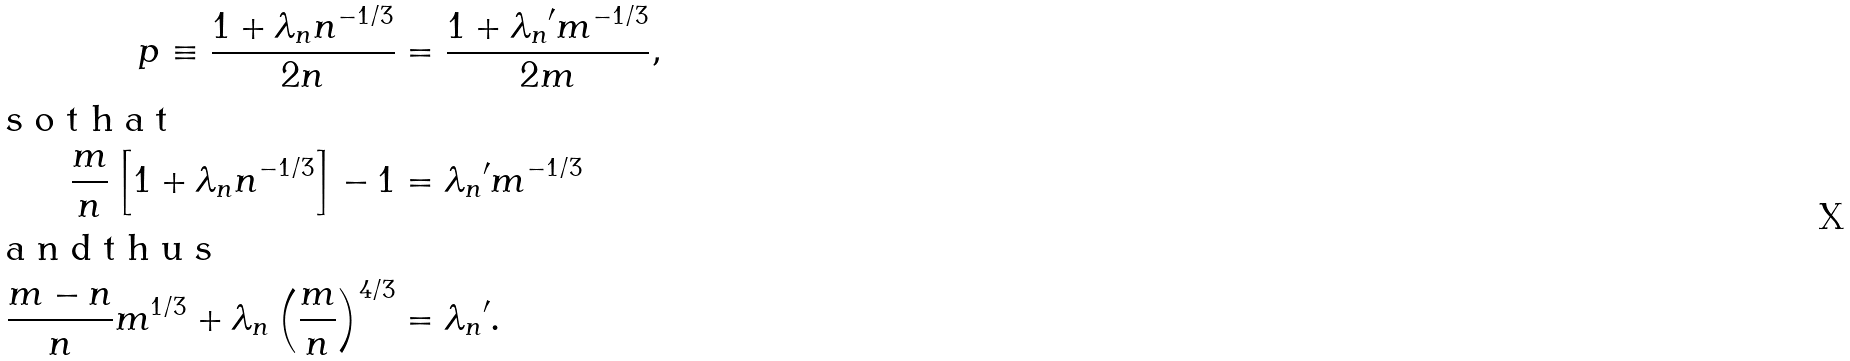Convert formula to latex. <formula><loc_0><loc_0><loc_500><loc_500>p \equiv \frac { 1 + { \lambda _ { n } } n ^ { - 1 / 3 } } { 2 n } & = \frac { 1 + { \lambda _ { n } } ^ { \prime } m ^ { - 1 / 3 } } { 2 m } , \\ \intertext { s o t h a t } \frac { m } { n } \left [ 1 + { \lambda _ { n } } n ^ { - 1 / 3 } \right ] - 1 & = { \lambda _ { n } } ^ { \prime } m ^ { - 1 / 3 } \\ \intertext { a n d t h u s } \frac { m - n } { n } m ^ { 1 / 3 } + { \lambda _ { n } } \left ( \frac { m } { n } \right ) ^ { 4 / 3 } & = { \lambda _ { n } } ^ { \prime } .</formula> 